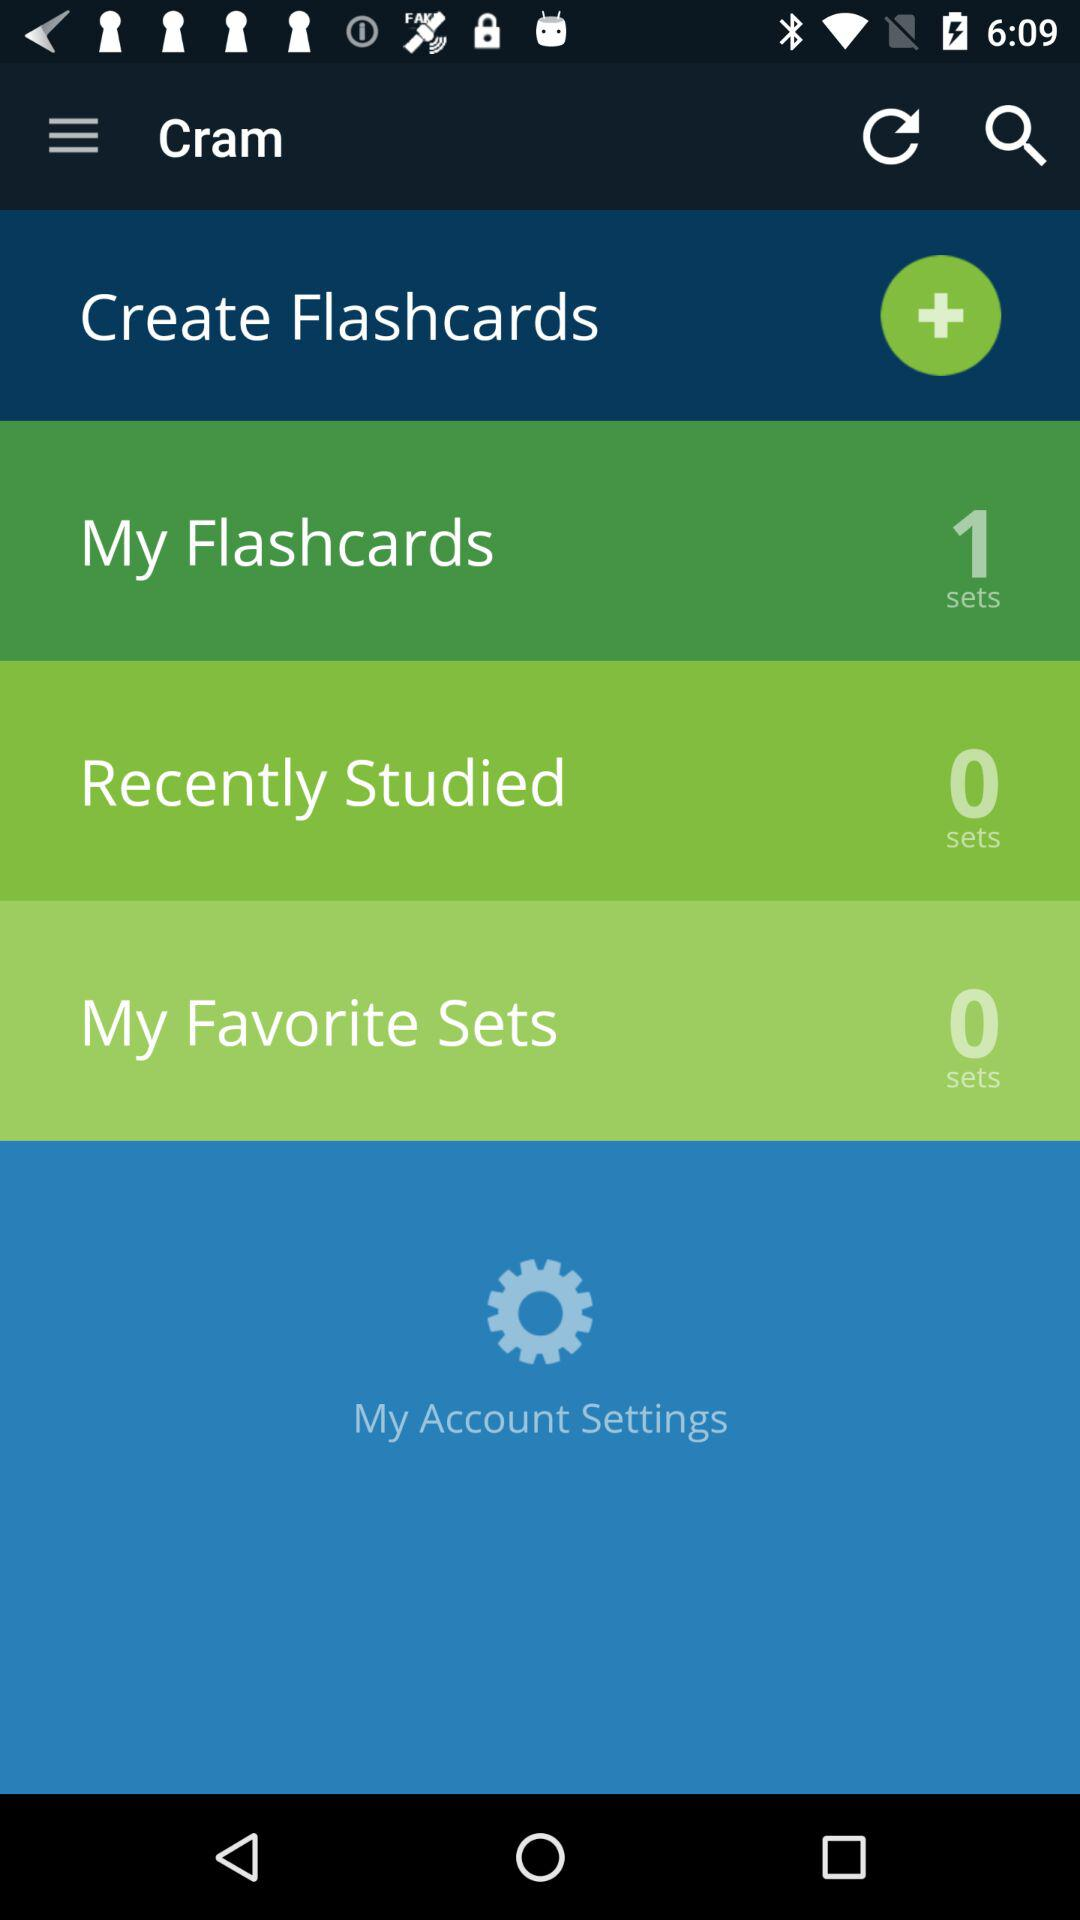How many more flashcard sets do I have than recently studied sets?
Answer the question using a single word or phrase. 1 